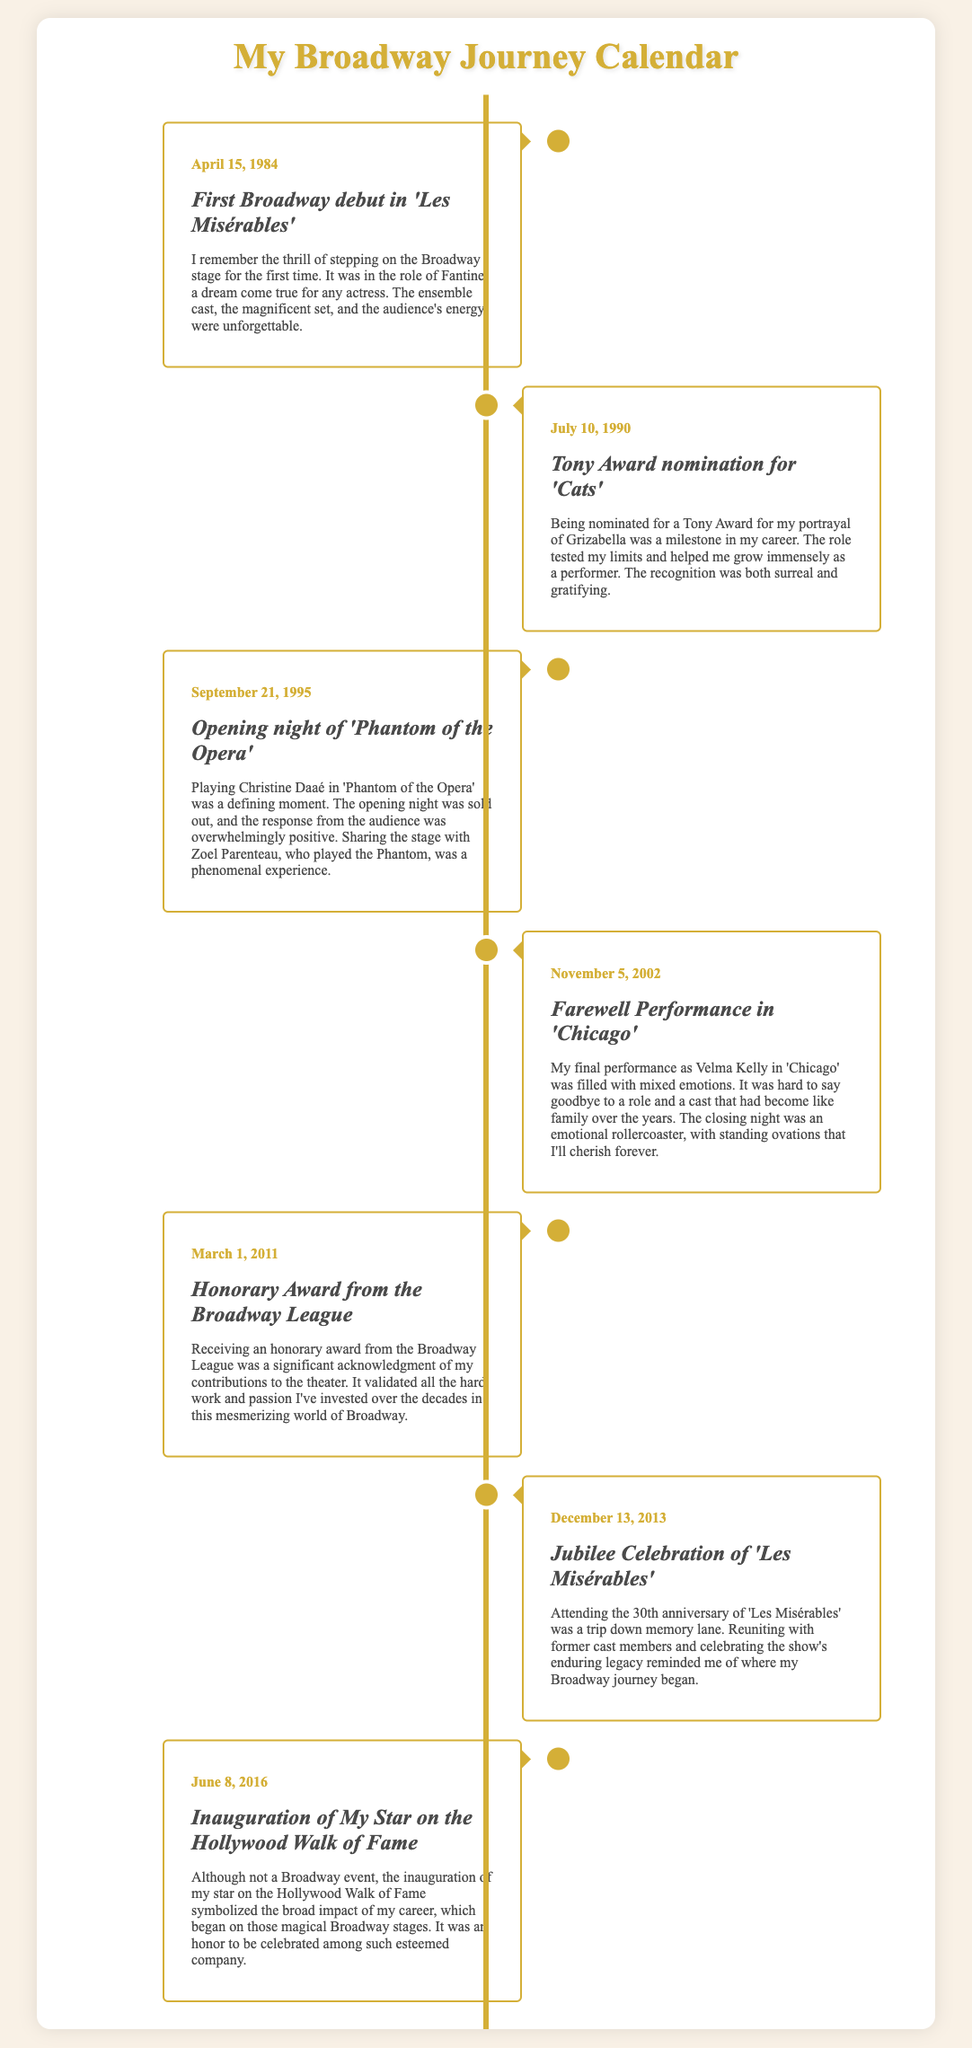What date did your Broadway debut occur? The document specifically states that the Broadway debut occurred on April 15, 1984.
Answer: April 15, 1984 Which role did you play in 'Les Misérables'? The document mentions that you played the role of Fantine in 'Les Misérables'.
Answer: Fantine What award were you nominated for on July 10, 1990? According to the document, you were nominated for a Tony Award for your role in 'Cats'.
Answer: Tony Award In what year did you receive the honorary award from the Broadway League? The document indicates that the honorary award was received on March 1, 2011.
Answer: 2011 Name one significant aspect of your performance in 'Phantom of the Opera'. The document highlights that sharing the stage with Zoel Parenteau was a phenomenal experience.
Answer: Zoel Parenteau What was the emotional experience of your farewell performance in 'Chicago'? The document indicates that the farewell performance was filled with mixed emotions.
Answer: Mixed emotions How many years after your Broadway debut did you attend the Jubilee Celebration of 'Les Misérables'? The document states that the Jubilee Celebration occurred on December 13, 2013, which is 29 years after the debut in 1984.
Answer: 29 years What is the title of the event that took place on June 8, 2016? The document specifies that the event was the inauguration of your star on the Hollywood Walk of Fame.
Answer: Inauguration of My Star on the Hollywood Walk of Fame 